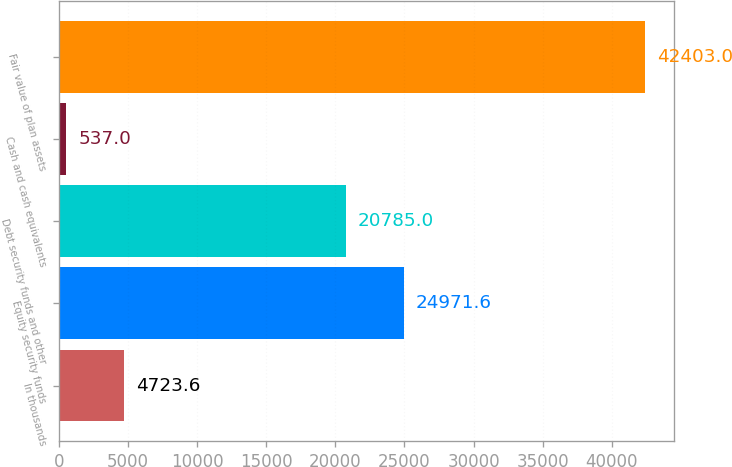<chart> <loc_0><loc_0><loc_500><loc_500><bar_chart><fcel>In thousands<fcel>Equity security funds<fcel>Debt security funds and other<fcel>Cash and cash equivalents<fcel>Fair value of plan assets<nl><fcel>4723.6<fcel>24971.6<fcel>20785<fcel>537<fcel>42403<nl></chart> 